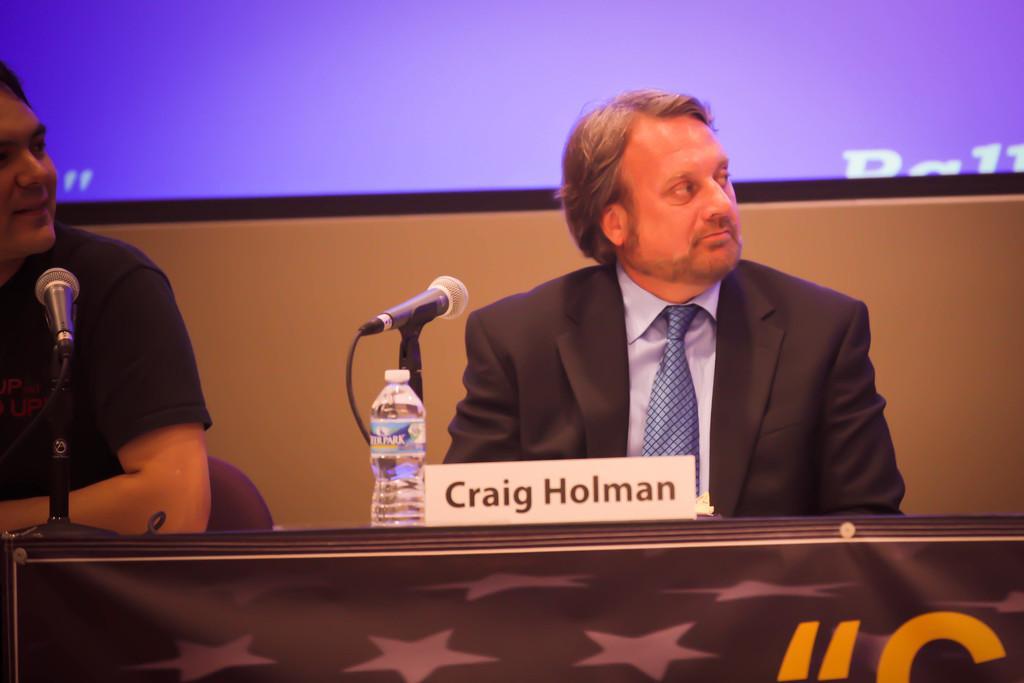How would you summarize this image in a sentence or two? There are two people sitting on the chairs. This is a table with a name board,water bottle and mike. This looks like a banner attached to the table. At background this looks like a screen. 